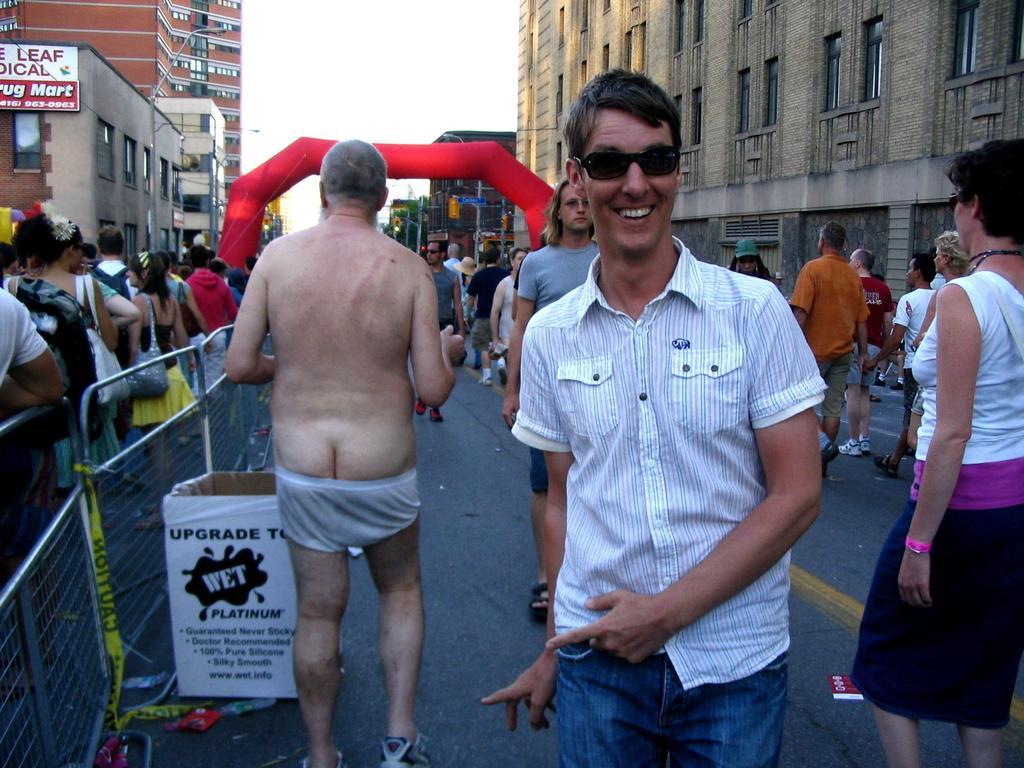Could you give a brief overview of what you see in this image? In this image we can see a few people on the road. And we can see the metal fencing. And we can see the many buildings and boards. And we can see the sky at the top. 